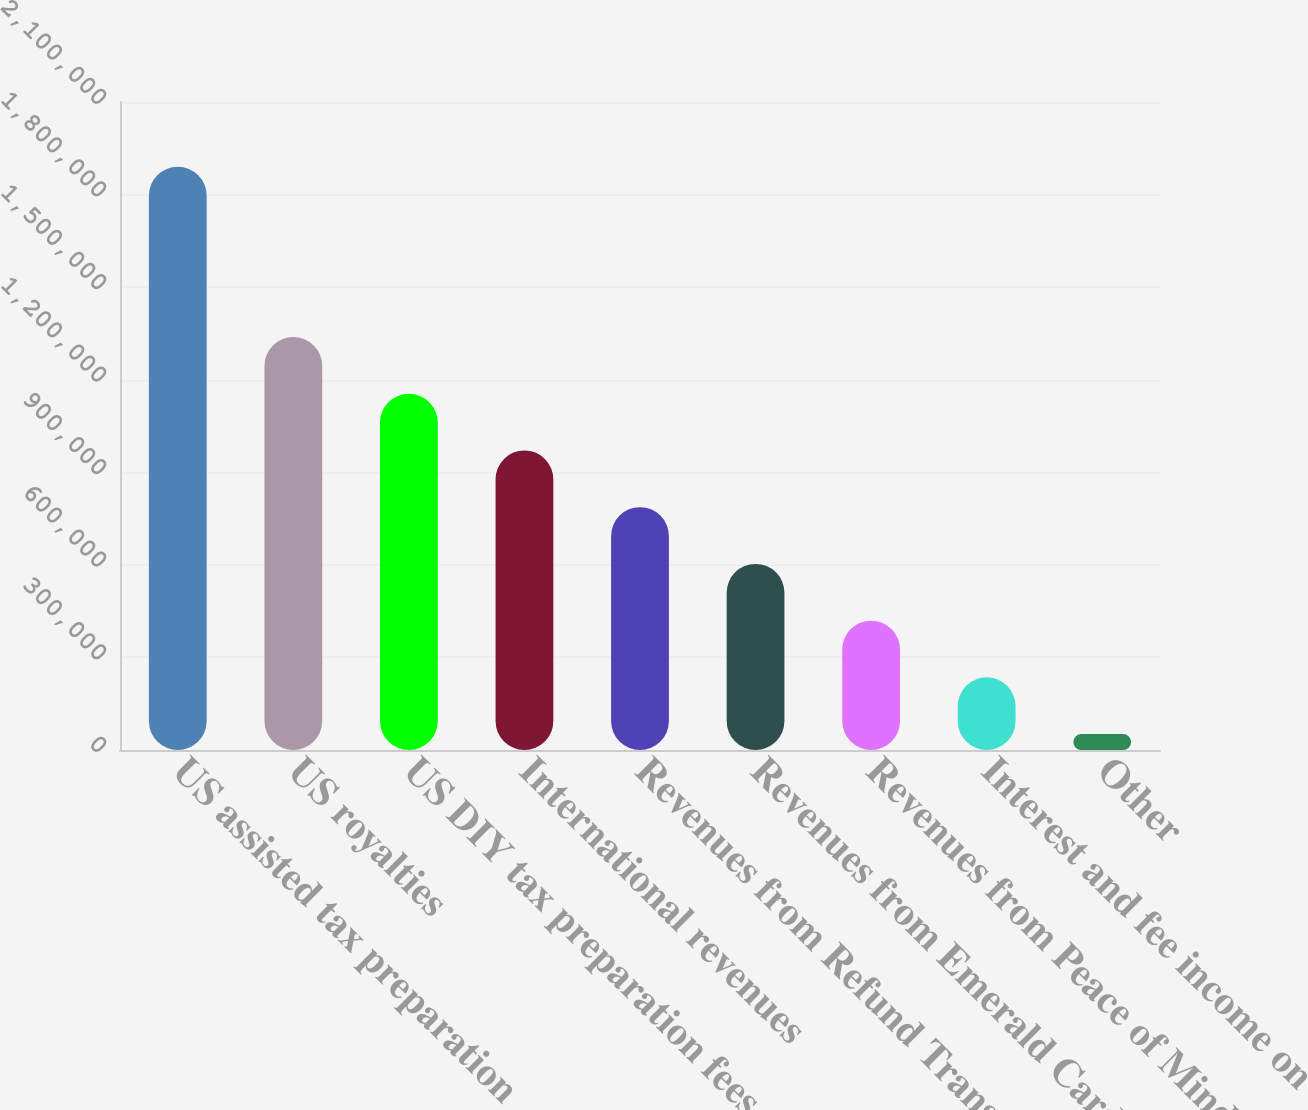Convert chart. <chart><loc_0><loc_0><loc_500><loc_500><bar_chart><fcel>US assisted tax preparation<fcel>US royalties<fcel>US DIY tax preparation fees<fcel>International revenues<fcel>Revenues from Refund Transfers<fcel>Revenues from Emerald Card®<fcel>Revenues from Peace of Mind®<fcel>Interest and fee income on<fcel>Other<nl><fcel>1.89018e+06<fcel>1.33858e+06<fcel>1.15472e+06<fcel>970856<fcel>786993<fcel>603129<fcel>419265<fcel>235402<fcel>51538<nl></chart> 